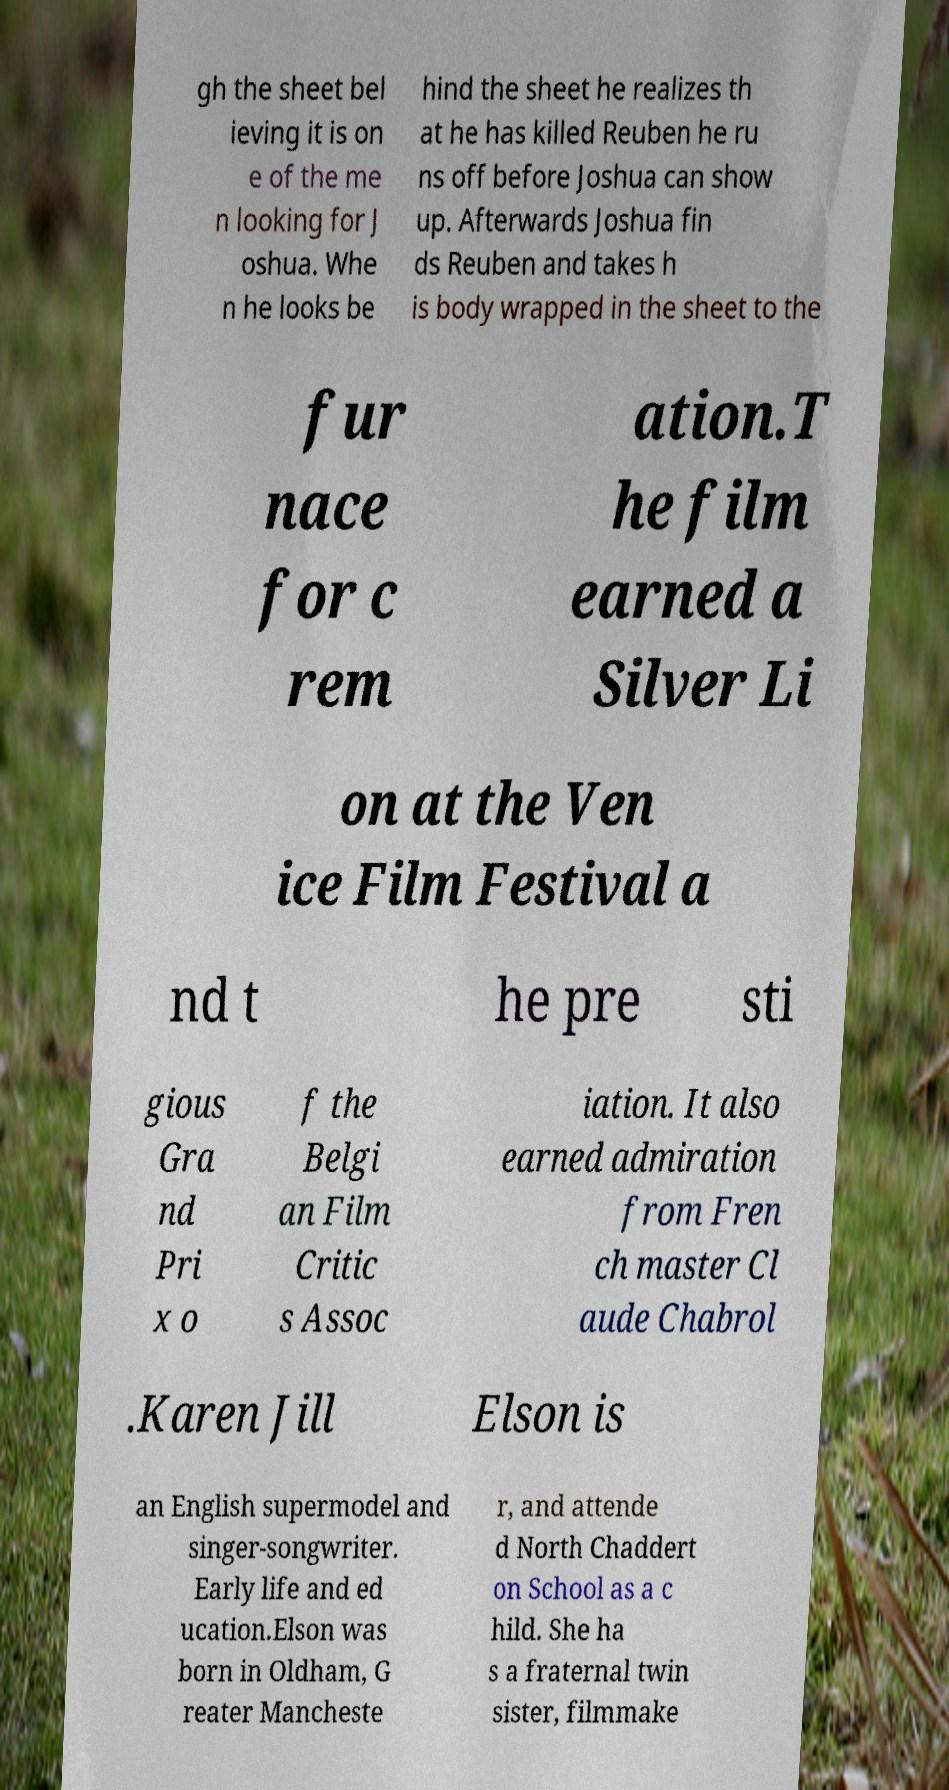Can you accurately transcribe the text from the provided image for me? gh the sheet bel ieving it is on e of the me n looking for J oshua. Whe n he looks be hind the sheet he realizes th at he has killed Reuben he ru ns off before Joshua can show up. Afterwards Joshua fin ds Reuben and takes h is body wrapped in the sheet to the fur nace for c rem ation.T he film earned a Silver Li on at the Ven ice Film Festival a nd t he pre sti gious Gra nd Pri x o f the Belgi an Film Critic s Assoc iation. It also earned admiration from Fren ch master Cl aude Chabrol .Karen Jill Elson is an English supermodel and singer-songwriter. Early life and ed ucation.Elson was born in Oldham, G reater Mancheste r, and attende d North Chaddert on School as a c hild. She ha s a fraternal twin sister, filmmake 